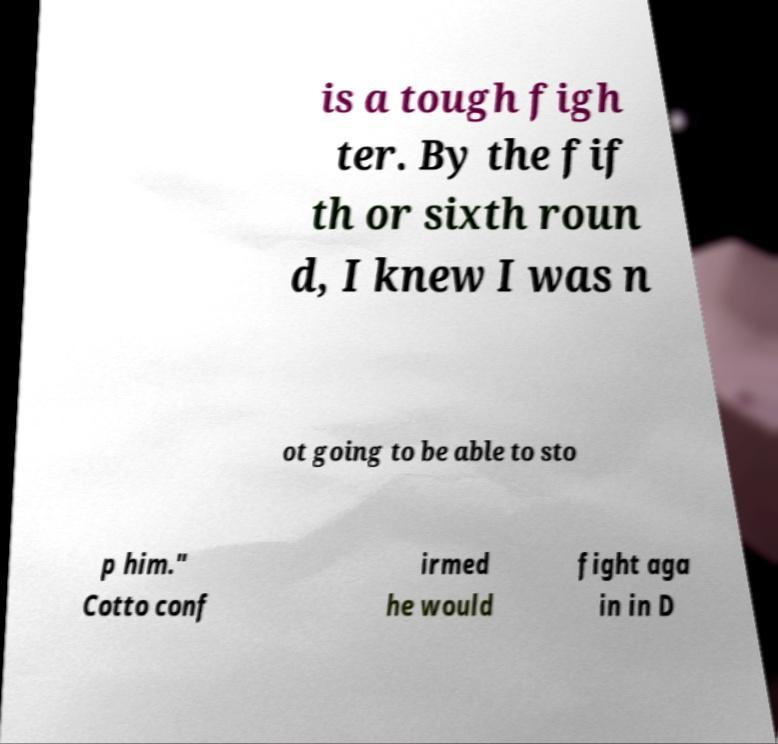Could you extract and type out the text from this image? is a tough figh ter. By the fif th or sixth roun d, I knew I was n ot going to be able to sto p him." Cotto conf irmed he would fight aga in in D 